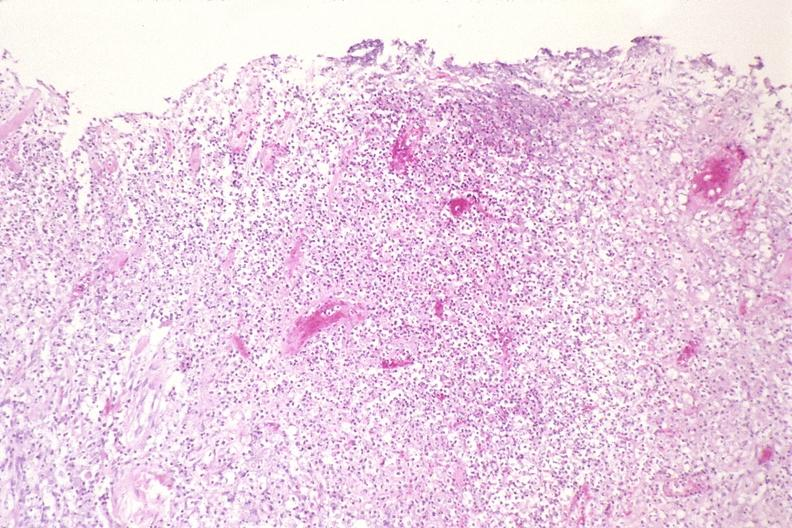what is present?
Answer the question using a single word or phrase. Respiratory 